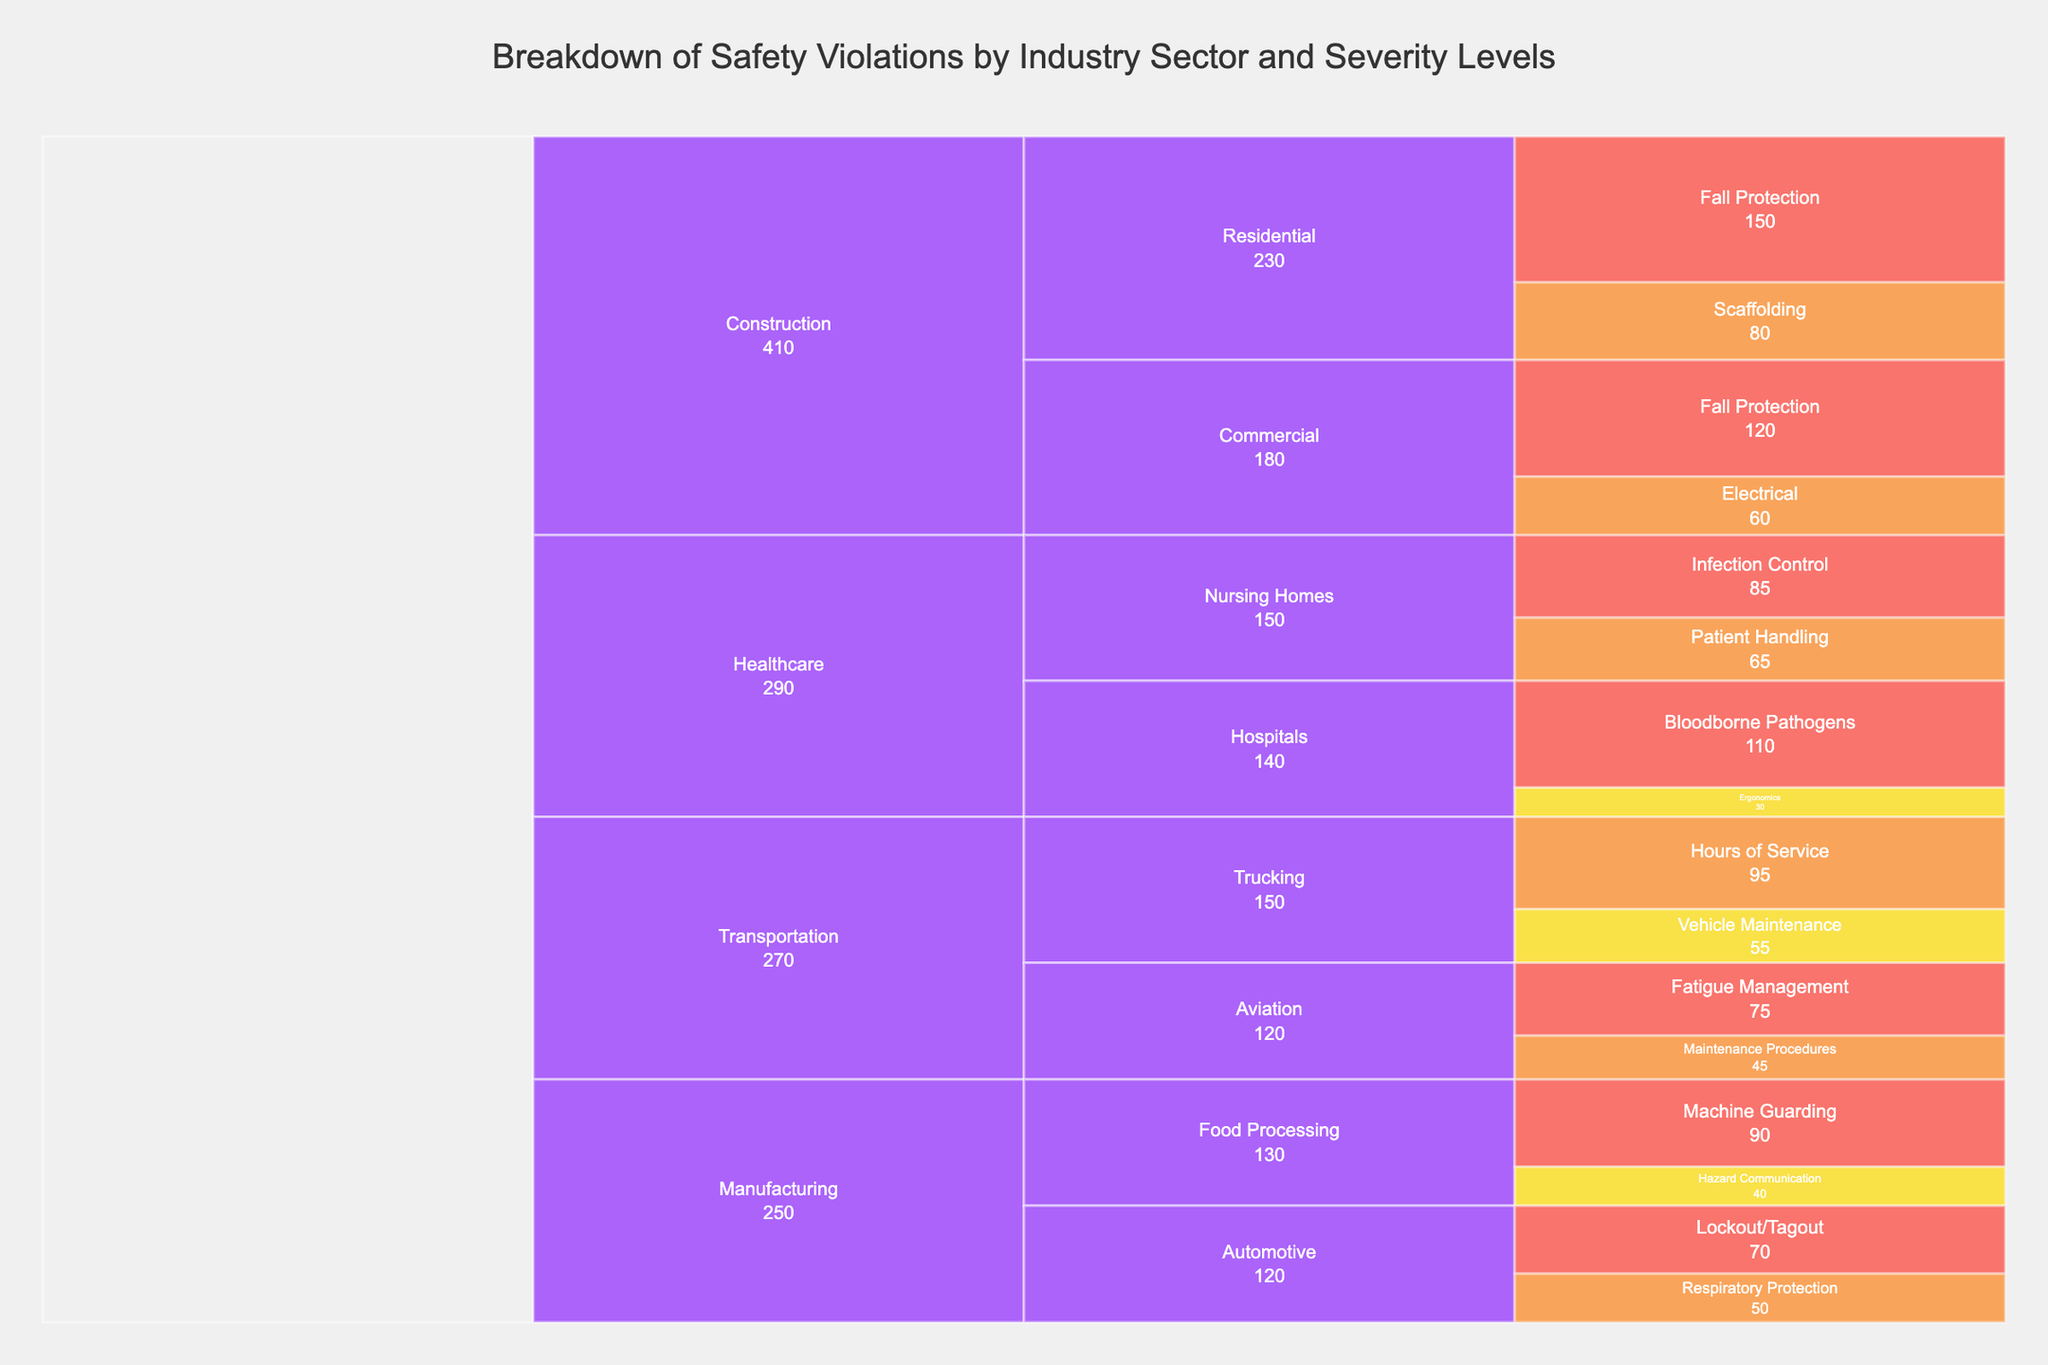What is the title of the chart? The title of the chart is located at the top of the figure and is displayed prominently. It reads "Breakdown of Safety Violations by Industry Sector and Severity Levels".
Answer: Breakdown of Safety Violations by Industry Sector and Severity Levels Which industry sector has the highest number of critical safety violations? The colors in the chart indicate severity levels. By identifying the sections with the most intense color representing 'Critical' (red), and summing up the counts, we see that Construction (Residential and Commercial combined) has the highest number of critical violations (150 + 120).
Answer: Construction How many moderate severity violations are there in the Healthcare industry? Moderate severity violations are yellow. By locating the yellow sections under Healthcare (Hospitals and Nursing Homes), we add up 30 (Ergonomics) from Hospitals and 0 from Nursing Homes.
Answer: 30 Which sector within the Manufacturing industry has the most safety violations? By examining the branches under Manufacturing, we compare Food Processing and Automotive. Food Processing has counts of 90 + 40 = 130, while Automotive has 70 + 50 = 120. Therefore, Food Processing has more violations.
Answer: Food Processing Compare the total number of serious violations in the Transportation industry to those in the Healthcare industry. For Transportation, we sum up serious violations (Trucking: 95, Aviation: 45), which gives 140. For Healthcare, serious violations are in Nursing Homes: 65. Hence, Transportation has more serious violations (140 vs 65).
Answer: Transportation What is the most common type of critical safety violation in the Construction industry? By identifying the 'Critical' segments in the Construction branches, we observe the counts under Fall Protection in both Residential (150) and Commercial (120). Combining these, Fall Protection is the most common critical violation (270 in total).
Answer: Fall Protection How does the number of fall protection violations in the Construction-Residential sector compare to the entire Healthcare industry? Fall Protection violations in Construction-Residential (150) are compared to the entire Healthcare, which includes Bloodborne Pathogens (110) and Infection Control (85), totaling 195. Construction-Residential has fewer fall protection violations than Healthcare's total (150 vs 195).
Answer: Healthcare What are the least common types of violations in the Manufacturing-Food Processing sector? The least common violation types in Food Processing can be identified by looking at the smaller values, which is Hazard Communication with 40 violations, compared to Machine Guarding with 90.
Answer: Hazard Communication How does the severity of violations in the Transportation-Aviation sector distribute? In the Transportation-Aviation sector, the violations are categorized as Critical (75 for Fatigue Management) and Serious (45 for Maintenance Procedures). By examining the segments, we see there are more Critical violations than Serious violations.
Answer: More Critical than Serious 